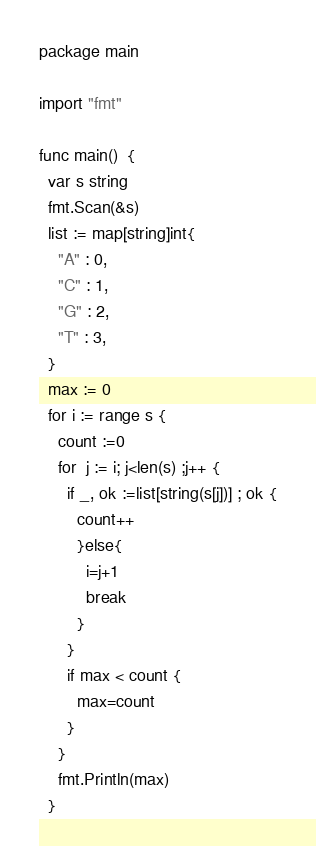Convert code to text. <code><loc_0><loc_0><loc_500><loc_500><_Go_>package main

import "fmt"

func main()  {
  var s string
  fmt.Scan(&s)
  list := map[string]int{
    "A" : 0,
    "C" : 1,
    "G" : 2,
    "T" : 3,
  }
  max := 0
  for i := range s {
    count :=0
    for  j := i; j<len(s) ;j++ {
      if _, ok :=list[string(s[j])] ; ok {
        count++
        }else{
          i=j+1
          break
        }
      }
      if max < count {
        max=count
      }
    }
    fmt.Println(max)
  }
</code> 